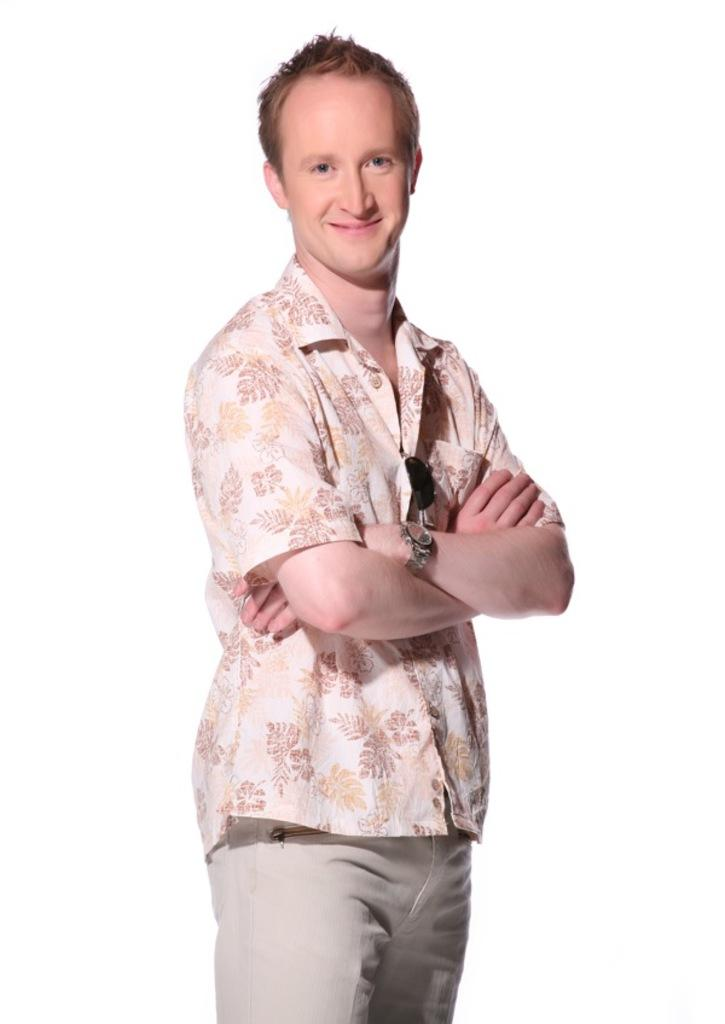What is the main subject of the image? There is a man standing in the middle of the image. What is the man's facial expression? The man has a smiling face. What color is the background of the image? The background of the image is white in color. How many girls are holding rakes in the image? There are no girls or rakes present in the image; it features a man with a smiling face against a white background. 